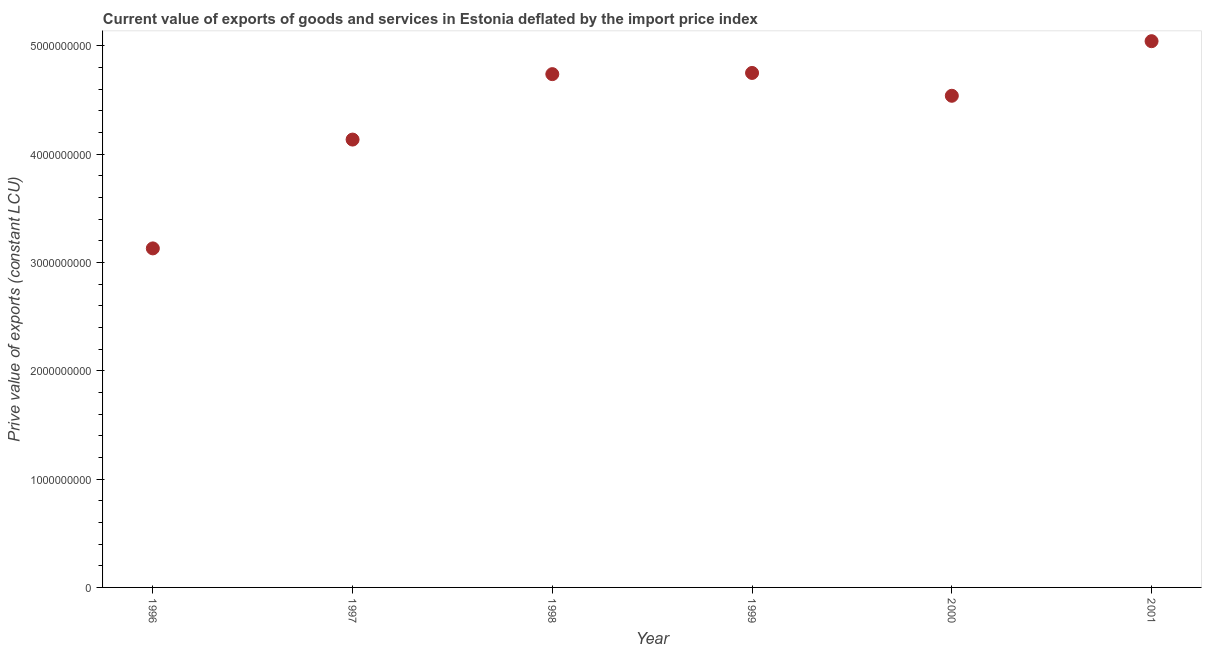What is the price value of exports in 1999?
Provide a succinct answer. 4.75e+09. Across all years, what is the maximum price value of exports?
Offer a very short reply. 5.04e+09. Across all years, what is the minimum price value of exports?
Ensure brevity in your answer.  3.13e+09. In which year was the price value of exports minimum?
Your answer should be very brief. 1996. What is the sum of the price value of exports?
Your answer should be compact. 2.63e+1. What is the difference between the price value of exports in 1997 and 1998?
Give a very brief answer. -6.04e+08. What is the average price value of exports per year?
Your answer should be very brief. 4.39e+09. What is the median price value of exports?
Keep it short and to the point. 4.64e+09. In how many years, is the price value of exports greater than 200000000 LCU?
Your response must be concise. 6. What is the ratio of the price value of exports in 1997 to that in 1998?
Give a very brief answer. 0.87. Is the price value of exports in 1999 less than that in 2001?
Make the answer very short. Yes. What is the difference between the highest and the second highest price value of exports?
Keep it short and to the point. 2.93e+08. Is the sum of the price value of exports in 1996 and 2001 greater than the maximum price value of exports across all years?
Offer a terse response. Yes. What is the difference between the highest and the lowest price value of exports?
Your answer should be compact. 1.91e+09. Does the price value of exports monotonically increase over the years?
Provide a succinct answer. No. How many dotlines are there?
Your response must be concise. 1. Does the graph contain grids?
Make the answer very short. No. What is the title of the graph?
Make the answer very short. Current value of exports of goods and services in Estonia deflated by the import price index. What is the label or title of the Y-axis?
Keep it short and to the point. Prive value of exports (constant LCU). What is the Prive value of exports (constant LCU) in 1996?
Your response must be concise. 3.13e+09. What is the Prive value of exports (constant LCU) in 1997?
Make the answer very short. 4.13e+09. What is the Prive value of exports (constant LCU) in 1998?
Your answer should be compact. 4.74e+09. What is the Prive value of exports (constant LCU) in 1999?
Your answer should be compact. 4.75e+09. What is the Prive value of exports (constant LCU) in 2000?
Provide a succinct answer. 4.54e+09. What is the Prive value of exports (constant LCU) in 2001?
Provide a succinct answer. 5.04e+09. What is the difference between the Prive value of exports (constant LCU) in 1996 and 1997?
Make the answer very short. -1.00e+09. What is the difference between the Prive value of exports (constant LCU) in 1996 and 1998?
Provide a short and direct response. -1.61e+09. What is the difference between the Prive value of exports (constant LCU) in 1996 and 1999?
Keep it short and to the point. -1.62e+09. What is the difference between the Prive value of exports (constant LCU) in 1996 and 2000?
Your answer should be very brief. -1.41e+09. What is the difference between the Prive value of exports (constant LCU) in 1996 and 2001?
Your answer should be very brief. -1.91e+09. What is the difference between the Prive value of exports (constant LCU) in 1997 and 1998?
Offer a very short reply. -6.04e+08. What is the difference between the Prive value of exports (constant LCU) in 1997 and 1999?
Your response must be concise. -6.15e+08. What is the difference between the Prive value of exports (constant LCU) in 1997 and 2000?
Your answer should be very brief. -4.04e+08. What is the difference between the Prive value of exports (constant LCU) in 1997 and 2001?
Provide a succinct answer. -9.08e+08. What is the difference between the Prive value of exports (constant LCU) in 1998 and 1999?
Provide a succinct answer. -1.10e+07. What is the difference between the Prive value of exports (constant LCU) in 1998 and 2000?
Provide a succinct answer. 2.00e+08. What is the difference between the Prive value of exports (constant LCU) in 1998 and 2001?
Make the answer very short. -3.04e+08. What is the difference between the Prive value of exports (constant LCU) in 1999 and 2000?
Your response must be concise. 2.11e+08. What is the difference between the Prive value of exports (constant LCU) in 1999 and 2001?
Offer a very short reply. -2.93e+08. What is the difference between the Prive value of exports (constant LCU) in 2000 and 2001?
Give a very brief answer. -5.04e+08. What is the ratio of the Prive value of exports (constant LCU) in 1996 to that in 1997?
Your answer should be compact. 0.76. What is the ratio of the Prive value of exports (constant LCU) in 1996 to that in 1998?
Make the answer very short. 0.66. What is the ratio of the Prive value of exports (constant LCU) in 1996 to that in 1999?
Keep it short and to the point. 0.66. What is the ratio of the Prive value of exports (constant LCU) in 1996 to that in 2000?
Your answer should be compact. 0.69. What is the ratio of the Prive value of exports (constant LCU) in 1996 to that in 2001?
Keep it short and to the point. 0.62. What is the ratio of the Prive value of exports (constant LCU) in 1997 to that in 1998?
Your response must be concise. 0.87. What is the ratio of the Prive value of exports (constant LCU) in 1997 to that in 1999?
Provide a short and direct response. 0.87. What is the ratio of the Prive value of exports (constant LCU) in 1997 to that in 2000?
Your answer should be compact. 0.91. What is the ratio of the Prive value of exports (constant LCU) in 1997 to that in 2001?
Your response must be concise. 0.82. What is the ratio of the Prive value of exports (constant LCU) in 1998 to that in 1999?
Provide a succinct answer. 1. What is the ratio of the Prive value of exports (constant LCU) in 1998 to that in 2000?
Offer a terse response. 1.04. What is the ratio of the Prive value of exports (constant LCU) in 1998 to that in 2001?
Make the answer very short. 0.94. What is the ratio of the Prive value of exports (constant LCU) in 1999 to that in 2000?
Provide a short and direct response. 1.05. What is the ratio of the Prive value of exports (constant LCU) in 1999 to that in 2001?
Make the answer very short. 0.94. What is the ratio of the Prive value of exports (constant LCU) in 2000 to that in 2001?
Provide a short and direct response. 0.9. 